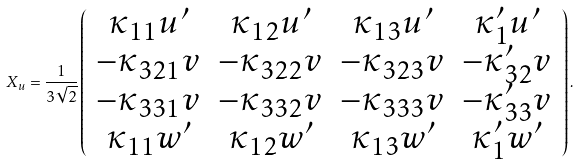<formula> <loc_0><loc_0><loc_500><loc_500>X _ { u } = \frac { 1 } { 3 \sqrt { 2 } } \left ( \begin{array} { c c c c } \kappa _ { 1 1 } u ^ { \prime } & \kappa _ { 1 2 } u ^ { \prime } & \kappa _ { 1 3 } u ^ { \prime } & \kappa ^ { \prime } _ { 1 } u ^ { \prime } \\ - \kappa _ { 3 2 1 } v & - \kappa _ { 3 2 2 } v & - \kappa _ { 3 2 3 } v & - \kappa ^ { \prime } _ { 3 2 } v \\ - \kappa _ { 3 3 1 } v & - \kappa _ { 3 3 2 } v & - \kappa _ { 3 3 3 } v & - \kappa ^ { \prime } _ { 3 3 } v \\ \kappa _ { 1 1 } w ^ { \prime } & \kappa _ { 1 2 } w ^ { \prime } & \kappa _ { 1 3 } w ^ { \prime } & \kappa ^ { \prime } _ { 1 } w ^ { \prime } \\ \end{array} \right ) .</formula> 